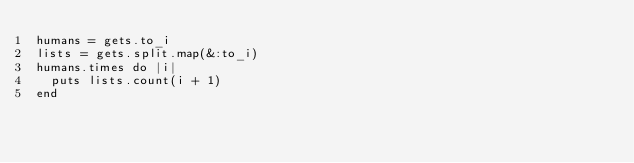Convert code to text. <code><loc_0><loc_0><loc_500><loc_500><_Ruby_>humans = gets.to_i
lists = gets.split.map(&:to_i)
humans.times do |i|
  puts lists.count(i + 1)
end</code> 